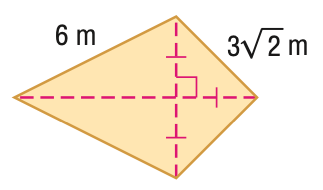Answer the mathemtical geometry problem and directly provide the correct option letter.
Question: Find the area of the figure in feet. Round to the nearest tenth, if necessary.
Choices: A: 24.6 B: 25.5 C: 31.2 D: 36 C 